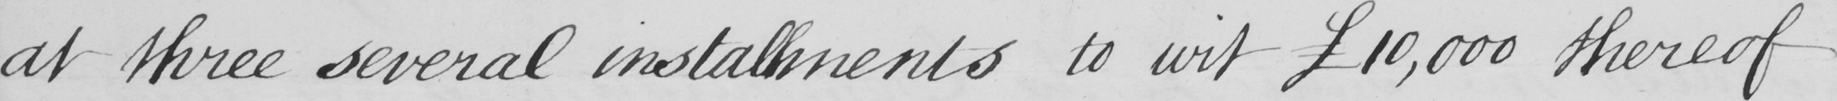Please transcribe the handwritten text in this image. at three several installments to wit  £10,000 thereof 